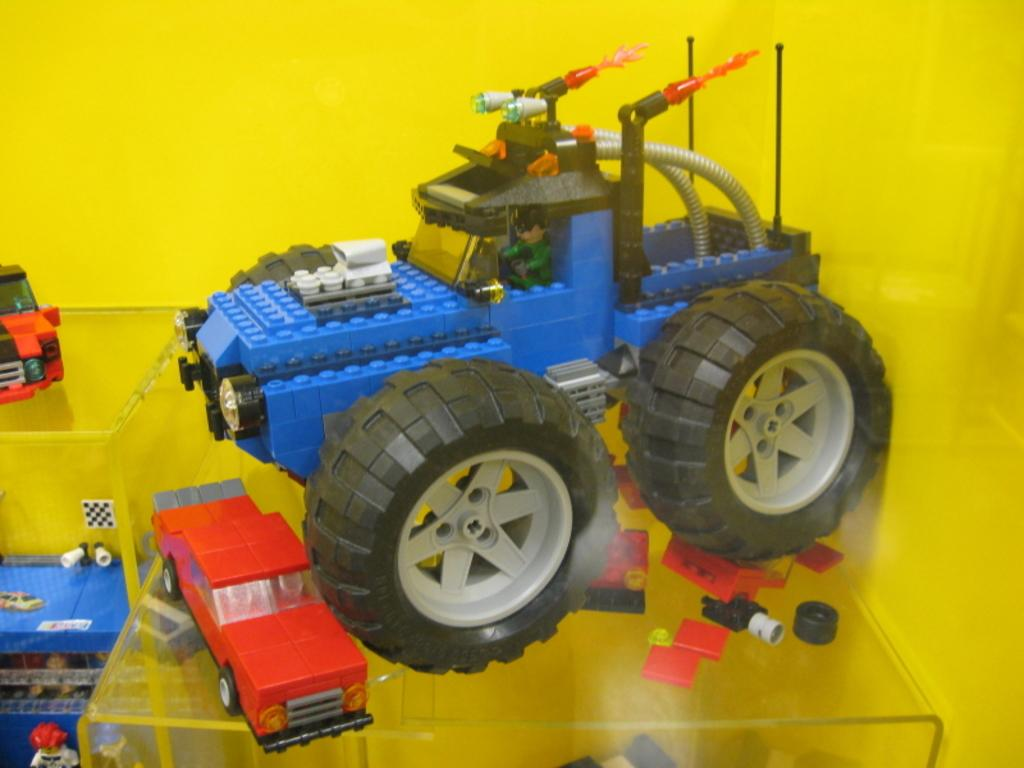What type of toys are present in the image? There are toy cars in the image. Where are the toy cars located? The toy cars are on a glass table. What type of power source is required for the baby to play with the yam in the image? There is no baby or yam present in the image, so this question cannot be answered. 